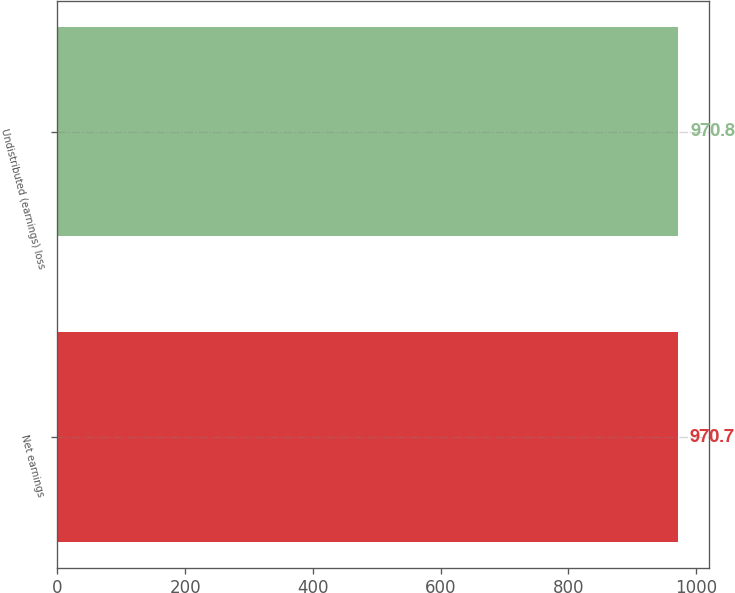<chart> <loc_0><loc_0><loc_500><loc_500><bar_chart><fcel>Net earnings<fcel>Undistributed (earnings) loss<nl><fcel>970.7<fcel>970.8<nl></chart> 